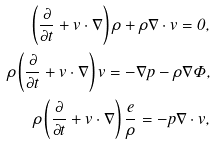Convert formula to latex. <formula><loc_0><loc_0><loc_500><loc_500>\left ( \frac { \partial } { \partial t } + v \cdot \nabla \right ) \rho + \rho \nabla \cdot v = 0 , \\ \rho \left ( \frac { \partial } { \partial t } + v \cdot \nabla \right ) v = - \nabla p - \rho \nabla \Phi , \\ \rho \left ( \frac { \partial } { \partial t } + v \cdot \nabla \right ) \frac { e } { \rho } = - p \nabla \cdot v ,</formula> 